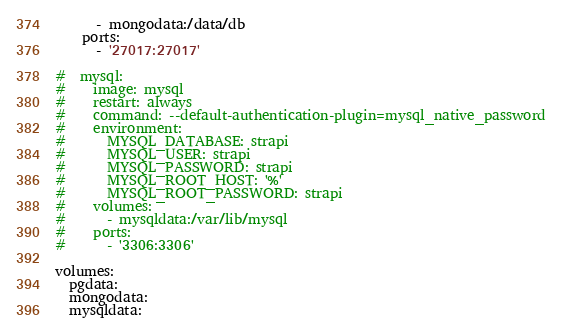<code> <loc_0><loc_0><loc_500><loc_500><_YAML_>      - mongodata:/data/db
    ports:
      - '27017:27017'

#  mysql:
#    image: mysql
#    restart: always
#    command: --default-authentication-plugin=mysql_native_password
#    environment:
#      MYSQL_DATABASE: strapi
#      MYSQL_USER: strapi
#      MYSQL_PASSWORD: strapi
#      MYSQL_ROOT_HOST: '%'
#      MYSQL_ROOT_PASSWORD: strapi
#    volumes:
#      - mysqldata:/var/lib/mysql
#    ports:
#      - '3306:3306'

volumes:
  pgdata:
  mongodata:
  mysqldata:
</code> 